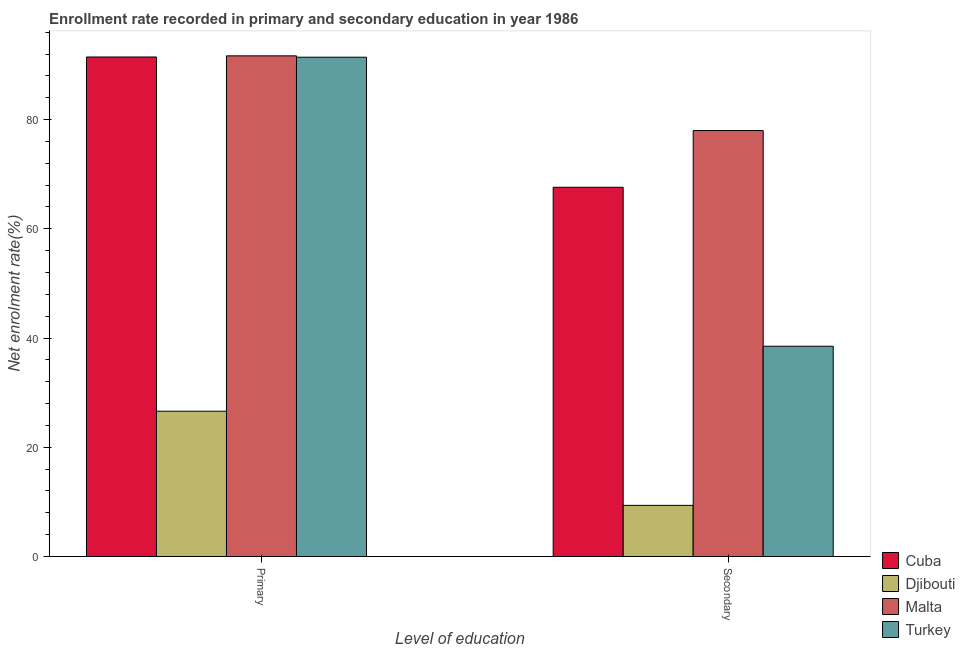How many different coloured bars are there?
Provide a short and direct response. 4. How many groups of bars are there?
Your answer should be compact. 2. Are the number of bars per tick equal to the number of legend labels?
Give a very brief answer. Yes. How many bars are there on the 2nd tick from the left?
Offer a terse response. 4. What is the label of the 1st group of bars from the left?
Your answer should be very brief. Primary. What is the enrollment rate in primary education in Malta?
Your response must be concise. 91.67. Across all countries, what is the maximum enrollment rate in secondary education?
Keep it short and to the point. 77.99. Across all countries, what is the minimum enrollment rate in primary education?
Provide a short and direct response. 26.61. In which country was the enrollment rate in secondary education maximum?
Give a very brief answer. Malta. In which country was the enrollment rate in primary education minimum?
Your answer should be compact. Djibouti. What is the total enrollment rate in primary education in the graph?
Offer a very short reply. 301.16. What is the difference between the enrollment rate in secondary education in Malta and that in Turkey?
Offer a very short reply. 39.49. What is the difference between the enrollment rate in primary education in Turkey and the enrollment rate in secondary education in Malta?
Your answer should be very brief. 13.43. What is the average enrollment rate in secondary education per country?
Keep it short and to the point. 48.37. What is the difference between the enrollment rate in secondary education and enrollment rate in primary education in Malta?
Give a very brief answer. -13.68. In how many countries, is the enrollment rate in secondary education greater than 56 %?
Your answer should be compact. 2. What is the ratio of the enrollment rate in primary education in Malta to that in Djibouti?
Offer a very short reply. 3.45. Is the enrollment rate in primary education in Djibouti less than that in Turkey?
Keep it short and to the point. Yes. In how many countries, is the enrollment rate in secondary education greater than the average enrollment rate in secondary education taken over all countries?
Offer a very short reply. 2. What does the 2nd bar from the left in Secondary represents?
Provide a succinct answer. Djibouti. What does the 4th bar from the right in Primary represents?
Your response must be concise. Cuba. How many bars are there?
Make the answer very short. 8. Are all the bars in the graph horizontal?
Your answer should be very brief. No. How many countries are there in the graph?
Offer a terse response. 4. Are the values on the major ticks of Y-axis written in scientific E-notation?
Your response must be concise. No. Where does the legend appear in the graph?
Make the answer very short. Bottom right. How many legend labels are there?
Offer a very short reply. 4. How are the legend labels stacked?
Offer a terse response. Vertical. What is the title of the graph?
Offer a terse response. Enrollment rate recorded in primary and secondary education in year 1986. Does "Bangladesh" appear as one of the legend labels in the graph?
Make the answer very short. No. What is the label or title of the X-axis?
Give a very brief answer. Level of education. What is the label or title of the Y-axis?
Your answer should be compact. Net enrolment rate(%). What is the Net enrolment rate(%) in Cuba in Primary?
Provide a succinct answer. 91.46. What is the Net enrolment rate(%) of Djibouti in Primary?
Your answer should be compact. 26.61. What is the Net enrolment rate(%) in Malta in Primary?
Keep it short and to the point. 91.67. What is the Net enrolment rate(%) of Turkey in Primary?
Your response must be concise. 91.42. What is the Net enrolment rate(%) of Cuba in Secondary?
Make the answer very short. 67.61. What is the Net enrolment rate(%) of Djibouti in Secondary?
Give a very brief answer. 9.37. What is the Net enrolment rate(%) in Malta in Secondary?
Provide a succinct answer. 77.99. What is the Net enrolment rate(%) in Turkey in Secondary?
Provide a succinct answer. 38.51. Across all Level of education, what is the maximum Net enrolment rate(%) in Cuba?
Give a very brief answer. 91.46. Across all Level of education, what is the maximum Net enrolment rate(%) in Djibouti?
Your answer should be very brief. 26.61. Across all Level of education, what is the maximum Net enrolment rate(%) in Malta?
Keep it short and to the point. 91.67. Across all Level of education, what is the maximum Net enrolment rate(%) of Turkey?
Keep it short and to the point. 91.42. Across all Level of education, what is the minimum Net enrolment rate(%) of Cuba?
Your response must be concise. 67.61. Across all Level of education, what is the minimum Net enrolment rate(%) of Djibouti?
Give a very brief answer. 9.37. Across all Level of education, what is the minimum Net enrolment rate(%) in Malta?
Provide a succinct answer. 77.99. Across all Level of education, what is the minimum Net enrolment rate(%) of Turkey?
Keep it short and to the point. 38.51. What is the total Net enrolment rate(%) in Cuba in the graph?
Your answer should be compact. 159.07. What is the total Net enrolment rate(%) in Djibouti in the graph?
Your answer should be compact. 35.97. What is the total Net enrolment rate(%) in Malta in the graph?
Provide a short and direct response. 169.66. What is the total Net enrolment rate(%) in Turkey in the graph?
Give a very brief answer. 129.93. What is the difference between the Net enrolment rate(%) in Cuba in Primary and that in Secondary?
Ensure brevity in your answer.  23.86. What is the difference between the Net enrolment rate(%) in Djibouti in Primary and that in Secondary?
Offer a terse response. 17.24. What is the difference between the Net enrolment rate(%) of Malta in Primary and that in Secondary?
Make the answer very short. 13.68. What is the difference between the Net enrolment rate(%) of Turkey in Primary and that in Secondary?
Give a very brief answer. 52.92. What is the difference between the Net enrolment rate(%) in Cuba in Primary and the Net enrolment rate(%) in Djibouti in Secondary?
Your answer should be compact. 82.1. What is the difference between the Net enrolment rate(%) in Cuba in Primary and the Net enrolment rate(%) in Malta in Secondary?
Offer a terse response. 13.47. What is the difference between the Net enrolment rate(%) in Cuba in Primary and the Net enrolment rate(%) in Turkey in Secondary?
Make the answer very short. 52.96. What is the difference between the Net enrolment rate(%) in Djibouti in Primary and the Net enrolment rate(%) in Malta in Secondary?
Give a very brief answer. -51.39. What is the difference between the Net enrolment rate(%) in Malta in Primary and the Net enrolment rate(%) in Turkey in Secondary?
Your answer should be compact. 53.17. What is the average Net enrolment rate(%) of Cuba per Level of education?
Give a very brief answer. 79.54. What is the average Net enrolment rate(%) of Djibouti per Level of education?
Give a very brief answer. 17.99. What is the average Net enrolment rate(%) of Malta per Level of education?
Your answer should be compact. 84.83. What is the average Net enrolment rate(%) of Turkey per Level of education?
Provide a succinct answer. 64.96. What is the difference between the Net enrolment rate(%) of Cuba and Net enrolment rate(%) of Djibouti in Primary?
Provide a succinct answer. 64.86. What is the difference between the Net enrolment rate(%) of Cuba and Net enrolment rate(%) of Malta in Primary?
Your answer should be compact. -0.21. What is the difference between the Net enrolment rate(%) of Djibouti and Net enrolment rate(%) of Malta in Primary?
Offer a very short reply. -65.07. What is the difference between the Net enrolment rate(%) of Djibouti and Net enrolment rate(%) of Turkey in Primary?
Your response must be concise. -64.82. What is the difference between the Net enrolment rate(%) of Malta and Net enrolment rate(%) of Turkey in Primary?
Make the answer very short. 0.25. What is the difference between the Net enrolment rate(%) in Cuba and Net enrolment rate(%) in Djibouti in Secondary?
Your answer should be very brief. 58.24. What is the difference between the Net enrolment rate(%) of Cuba and Net enrolment rate(%) of Malta in Secondary?
Offer a terse response. -10.38. What is the difference between the Net enrolment rate(%) of Cuba and Net enrolment rate(%) of Turkey in Secondary?
Offer a very short reply. 29.1. What is the difference between the Net enrolment rate(%) in Djibouti and Net enrolment rate(%) in Malta in Secondary?
Provide a short and direct response. -68.63. What is the difference between the Net enrolment rate(%) in Djibouti and Net enrolment rate(%) in Turkey in Secondary?
Ensure brevity in your answer.  -29.14. What is the difference between the Net enrolment rate(%) in Malta and Net enrolment rate(%) in Turkey in Secondary?
Provide a succinct answer. 39.49. What is the ratio of the Net enrolment rate(%) in Cuba in Primary to that in Secondary?
Offer a terse response. 1.35. What is the ratio of the Net enrolment rate(%) in Djibouti in Primary to that in Secondary?
Make the answer very short. 2.84. What is the ratio of the Net enrolment rate(%) of Malta in Primary to that in Secondary?
Offer a terse response. 1.18. What is the ratio of the Net enrolment rate(%) in Turkey in Primary to that in Secondary?
Ensure brevity in your answer.  2.37. What is the difference between the highest and the second highest Net enrolment rate(%) in Cuba?
Keep it short and to the point. 23.86. What is the difference between the highest and the second highest Net enrolment rate(%) in Djibouti?
Your response must be concise. 17.24. What is the difference between the highest and the second highest Net enrolment rate(%) in Malta?
Your response must be concise. 13.68. What is the difference between the highest and the second highest Net enrolment rate(%) of Turkey?
Provide a succinct answer. 52.92. What is the difference between the highest and the lowest Net enrolment rate(%) of Cuba?
Provide a succinct answer. 23.86. What is the difference between the highest and the lowest Net enrolment rate(%) of Djibouti?
Your answer should be compact. 17.24. What is the difference between the highest and the lowest Net enrolment rate(%) of Malta?
Provide a short and direct response. 13.68. What is the difference between the highest and the lowest Net enrolment rate(%) of Turkey?
Ensure brevity in your answer.  52.92. 